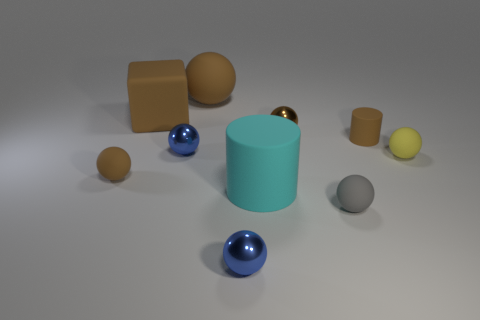Subtract all rubber spheres. How many spheres are left? 3 Subtract all blue spheres. How many spheres are left? 5 Subtract all red cylinders. How many brown balls are left? 3 Subtract 0 yellow cubes. How many objects are left? 10 Subtract all cylinders. How many objects are left? 8 Subtract 6 spheres. How many spheres are left? 1 Subtract all blue cylinders. Subtract all purple balls. How many cylinders are left? 2 Subtract all tiny green shiny objects. Subtract all large cyan matte cylinders. How many objects are left? 9 Add 5 tiny metallic things. How many tiny metallic things are left? 8 Add 1 small gray balls. How many small gray balls exist? 2 